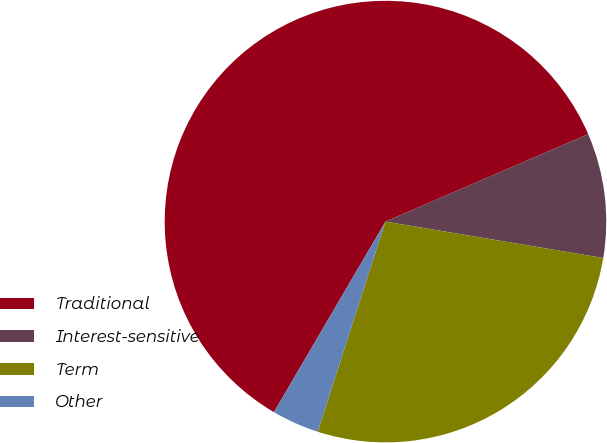Convert chart to OTSL. <chart><loc_0><loc_0><loc_500><loc_500><pie_chart><fcel>Traditional<fcel>Interest-sensitive<fcel>Term<fcel>Other<nl><fcel>60.08%<fcel>9.12%<fcel>27.33%<fcel>3.46%<nl></chart> 